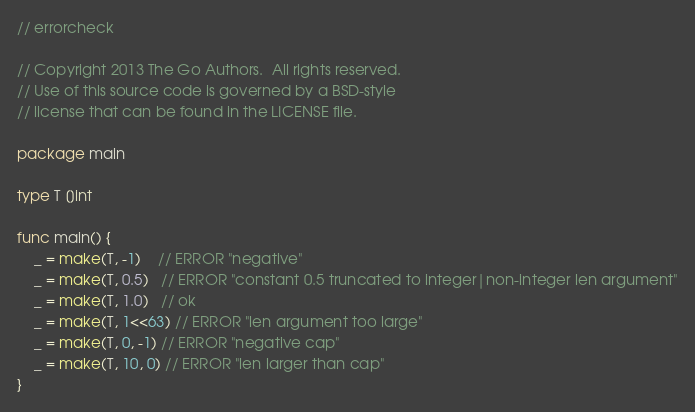Convert code to text. <code><loc_0><loc_0><loc_500><loc_500><_Go_>// errorcheck

// Copyright 2013 The Go Authors.  All rights reserved.
// Use of this source code is governed by a BSD-style
// license that can be found in the LICENSE file.

package main

type T []int

func main() {
	_ = make(T, -1)    // ERROR "negative"
	_ = make(T, 0.5)   // ERROR "constant 0.5 truncated to integer|non-integer len argument"
	_ = make(T, 1.0)   // ok
	_ = make(T, 1<<63) // ERROR "len argument too large"
	_ = make(T, 0, -1) // ERROR "negative cap"
	_ = make(T, 10, 0) // ERROR "len larger than cap"
}
</code> 